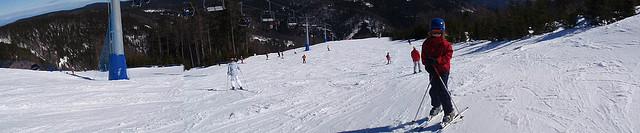Are they skiing?
Quick response, please. Yes. What is on the ground?
Concise answer only. Snow. Where are the people skiing?
Short answer required. Mountain. Does this image appear to have been captured by a professional photographer?
Short answer required. No. What kind of skiing is this?
Keep it brief. Downhill. 